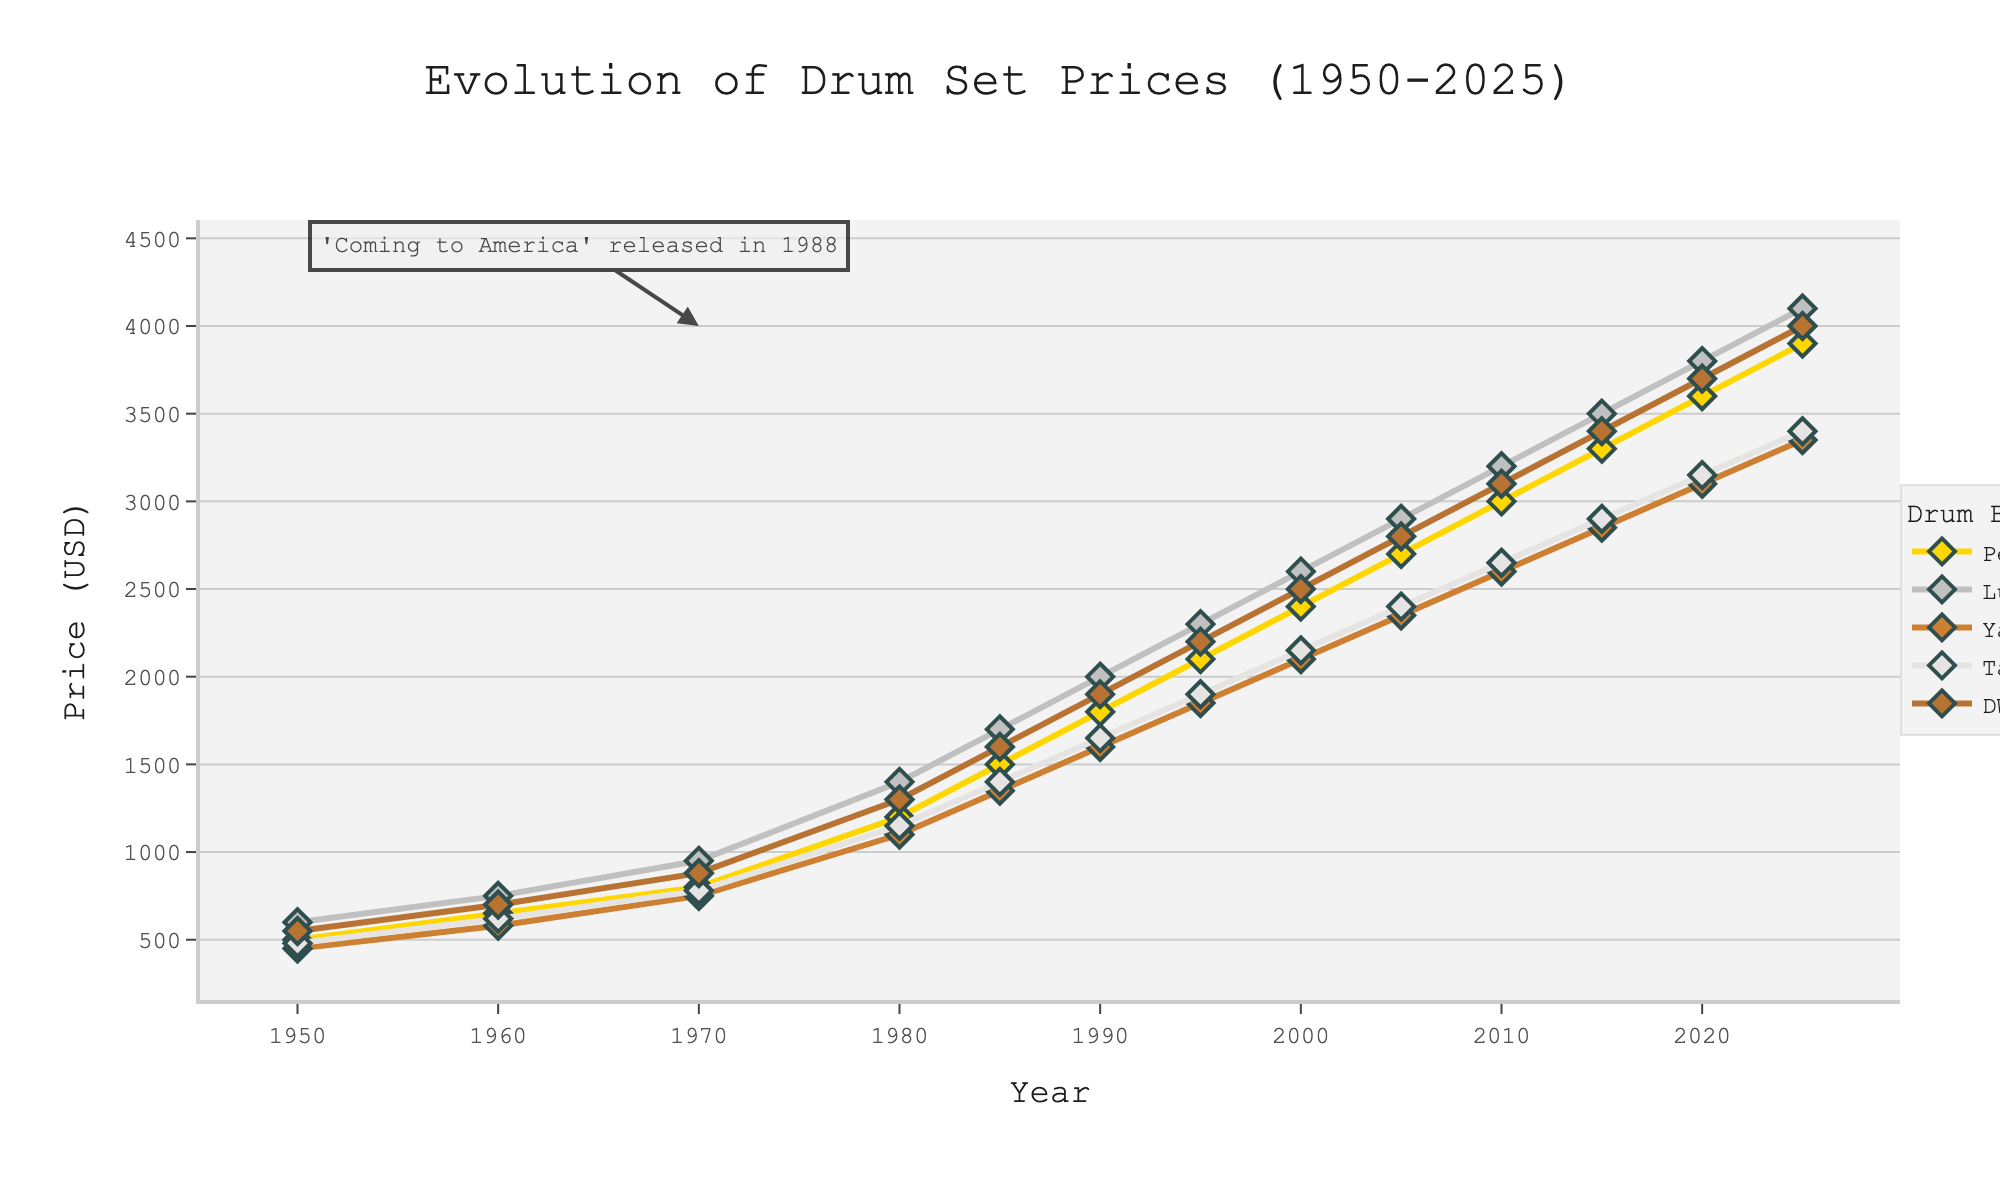What is the current price of a DW drum set in 2025? Look at the data point for DW in the year 2025.
Answer: 4000 Which drum brand had the highest price in 1980? Compare the prices for each brand in the year 1980.
Answer: Ludwig By how much did the price of Yamaha drum sets increase from 1950 to 2025? Subtract the price of Yamaha drum sets in 1950 from the price in 2025.
Answer: 2900 Which brand saw the steepest increase in price between 1980 and 1985? Calculate the difference in prices between 1980 and 1985 for each brand. The brand with the largest difference is the answer.
Answer: Ludwig What was the average price of all the drum brands in 1990? Add up the prices for all brands in 1990 and divide by the number of brands (5).
Answer: \( \frac{(1800 + 2000 + 1600 + 1650 + 1900)}{5} = 1790 \) Compare the price trends of Pearl and Tama drum sets. Which one has consistently higher prices over the years? Compare Pearl and Tama prices year by year.
Answer: Pearl In what year did the price of Pearl drum sets first exceed 2000 USD? Look for the year in which Pearl's price crossed 2000 USD for the first time.
Answer: 2000 By what percentage did the price of Ludwig drum sets increase from 1950 to 1980? Calculate the percentage increase using the formula \( \left( \frac{(Price_{1980} - Price_{1950})}{Price_{1950}} \right) \times 100 \).
Answer: \( \left( \frac{(1400 - 600)}{600} \right) \times 100 = 133.33 \% \) Based on the trend, what could be the expected price of a Yamaha drum set in 2030 if the current trend continues? Observe the trend of Yamaha prices and project the next value based on the consistent increments every 5 years.
Answer: Approximately 3600 